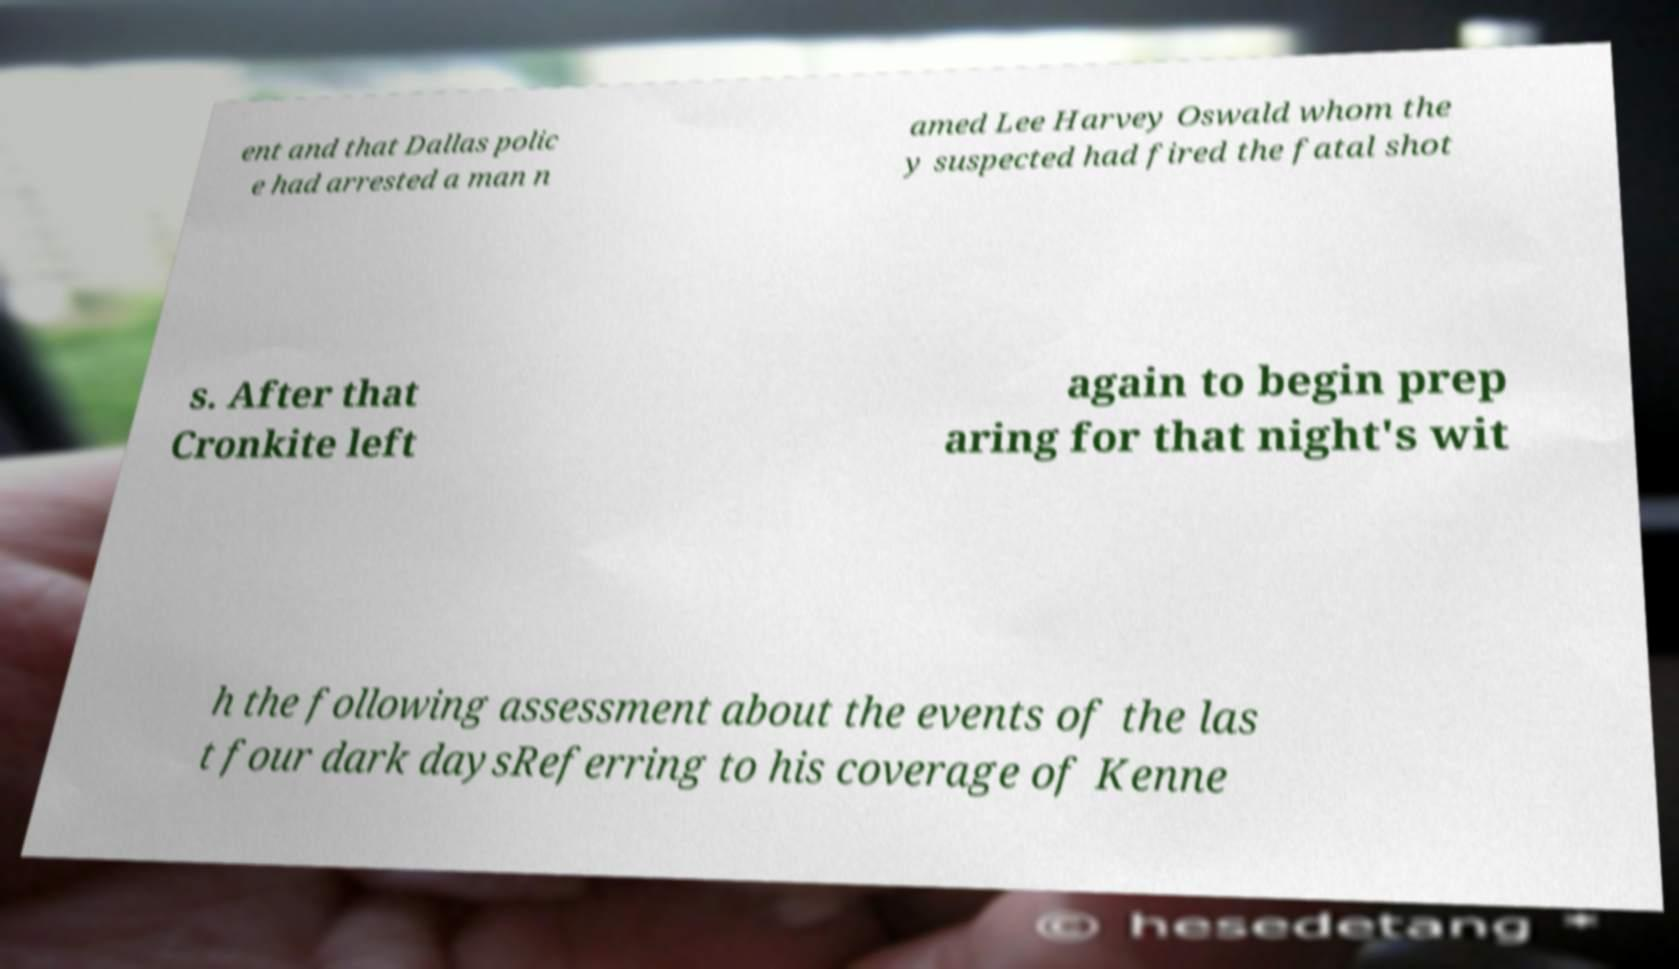There's text embedded in this image that I need extracted. Can you transcribe it verbatim? ent and that Dallas polic e had arrested a man n amed Lee Harvey Oswald whom the y suspected had fired the fatal shot s. After that Cronkite left again to begin prep aring for that night's wit h the following assessment about the events of the las t four dark daysReferring to his coverage of Kenne 